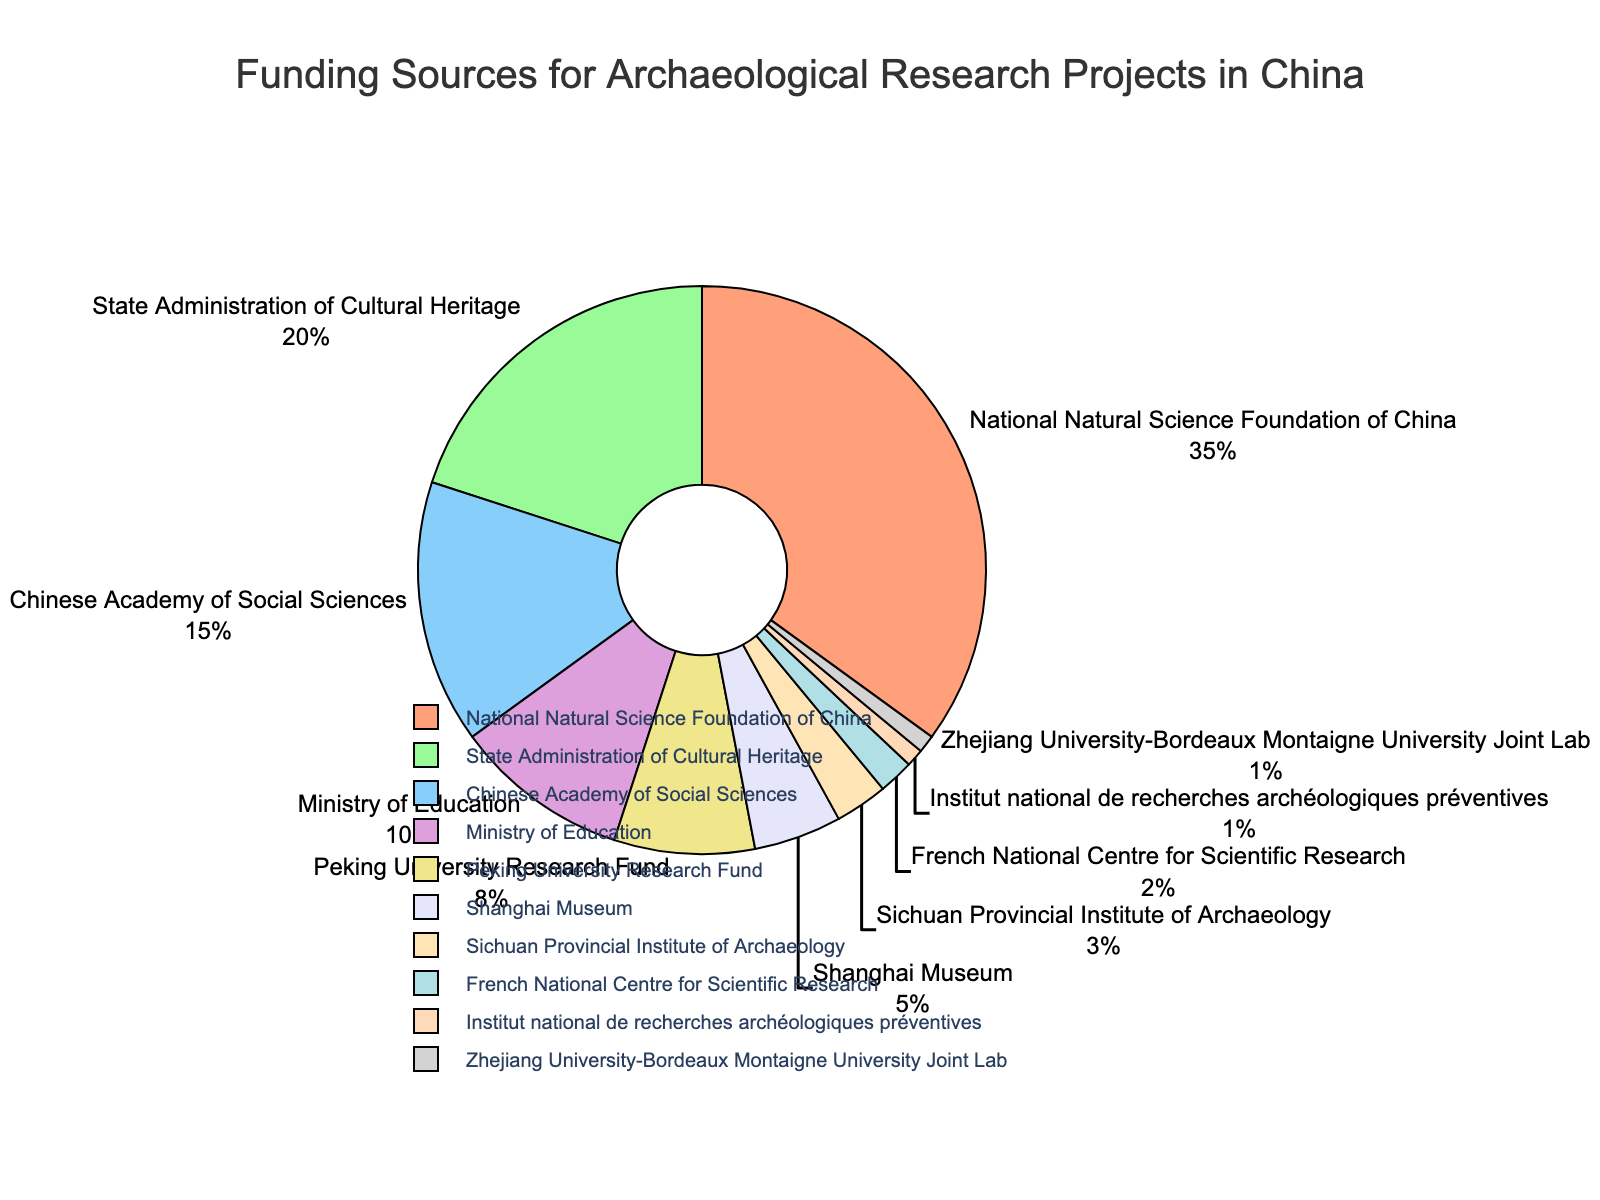What's the largest funding source? The National Natural Science Foundation of China is labeled with the highest percentage.
Answer: National Natural Science Foundation of China What is the combined percentage of funding from the Chinese Academy of Social Sciences and the Ministry of Education? The figure shows 15% for the Chinese Academy of Social Sciences and 10% for the Ministry of Education. Adding these gives 15 + 10 = 25%.
Answer: 25% Which funding source provides more support: The State Administration of Cultural Heritage or the Peking University Research Fund? The pie chart shows 20% for the State Administration of Cultural Heritage and 8% for the Peking University Research Fund. 20% is greater than 8%.
Answer: State Administration of Cultural Heritage What percentage of funding do smaller sources (those contributing less than 5%) collectively provide? Summing up the percentages of the Shanghai Museum (5%), Sichuan Provincial Institute of Archaeology (3%), French National Centre for Scientific Research (2%), Institut national de recherches archéologiques préventives (1%), and Zhejiang University-Bordeaux Montaigne University Joint Lab (1%): 5 + 3 + 2 + 1 + 1 = 12%.
Answer: 12% Which organization provides the smallest proportion of funding, and what is that percentage? The Institut national de recherches archéologiques préventives and the Zhejiang University-Bordeaux Montaigne University Joint Lab both have the smallest percentage, which is 1%.
Answer: Institut national de recherches archéologiques préventives and Zhejiang University-Bordeaux Montaigne University Joint Lab, 1% How much higher is the funding percentage from the National Natural Science Foundation of China compared to the French National Centre for Scientific Research? The funding from the National Natural Science Foundation of China is 35%, while from the French National Centre for Scientific Research it is 2%. The difference is 35 - 2 = 33%.
Answer: 33% What are the combined percentages of funding sources that are non-Chinese organizations? The French National Centre for Scientific Research and the Institut national de recherches archéologiques préventives are non-Chinese organizations, contributing 2% and 1% respectively. Their combined percentage is 2 + 1 = 3%.
Answer: 3% Which has a higher percentage: The Ministry of Education or Shanghai Museum? The pie chart indicates that the Ministry of Education has 10% funding, while Shanghai Museum has 5%. 10% is greater than 5%.
Answer: Ministry of Education 